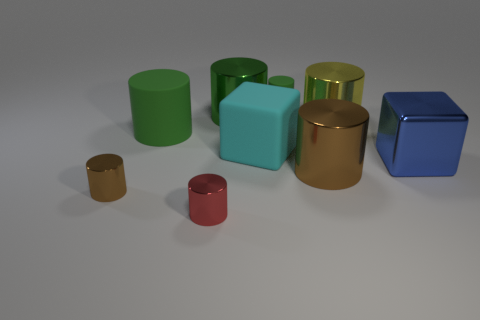Are there more big yellow things on the right side of the yellow cylinder than red cylinders?
Offer a terse response. No. How many metallic things are large blocks or big yellow balls?
Make the answer very short. 1. What size is the metal cylinder that is both behind the metal block and to the left of the large yellow metal object?
Offer a very short reply. Large. Is there a metallic cylinder in front of the brown thing that is right of the big rubber cylinder?
Offer a terse response. Yes. There is a big yellow cylinder; what number of small green cylinders are in front of it?
Your answer should be very brief. 0. There is a small matte thing that is the same shape as the red shiny object; what color is it?
Give a very brief answer. Green. Are the small cylinder behind the blue shiny thing and the big green thing behind the big yellow object made of the same material?
Your answer should be compact. No. Do the rubber cube and the matte cylinder that is on the right side of the red object have the same color?
Ensure brevity in your answer.  No. The small thing that is both behind the tiny red thing and in front of the tiny rubber cylinder has what shape?
Keep it short and to the point. Cylinder. What number of small blue shiny balls are there?
Provide a succinct answer. 0. 